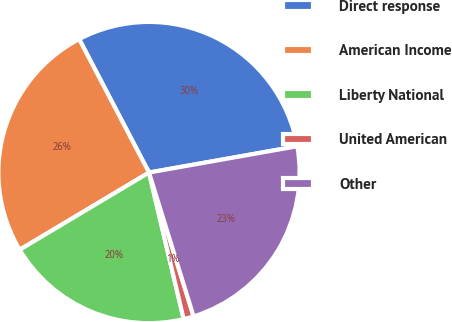Convert chart. <chart><loc_0><loc_0><loc_500><loc_500><pie_chart><fcel>Direct response<fcel>American Income<fcel>Liberty National<fcel>United American<fcel>Other<nl><fcel>29.88%<fcel>25.89%<fcel>20.13%<fcel>1.09%<fcel>23.01%<nl></chart> 